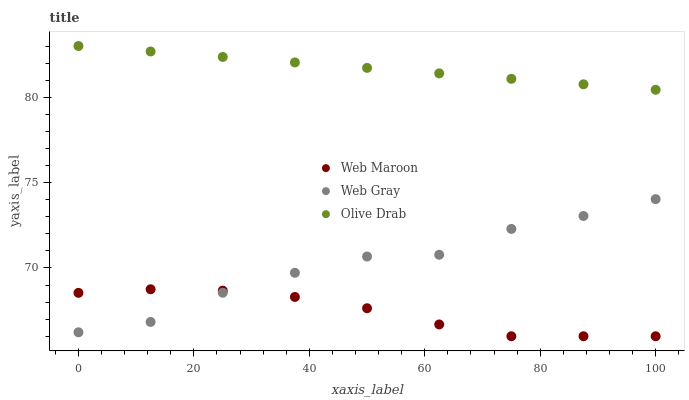Does Web Maroon have the minimum area under the curve?
Answer yes or no. Yes. Does Olive Drab have the maximum area under the curve?
Answer yes or no. Yes. Does Olive Drab have the minimum area under the curve?
Answer yes or no. No. Does Web Maroon have the maximum area under the curve?
Answer yes or no. No. Is Olive Drab the smoothest?
Answer yes or no. Yes. Is Web Gray the roughest?
Answer yes or no. Yes. Is Web Maroon the smoothest?
Answer yes or no. No. Is Web Maroon the roughest?
Answer yes or no. No. Does Web Maroon have the lowest value?
Answer yes or no. Yes. Does Olive Drab have the lowest value?
Answer yes or no. No. Does Olive Drab have the highest value?
Answer yes or no. Yes. Does Web Maroon have the highest value?
Answer yes or no. No. Is Web Maroon less than Olive Drab?
Answer yes or no. Yes. Is Olive Drab greater than Web Gray?
Answer yes or no. Yes. Does Web Gray intersect Web Maroon?
Answer yes or no. Yes. Is Web Gray less than Web Maroon?
Answer yes or no. No. Is Web Gray greater than Web Maroon?
Answer yes or no. No. Does Web Maroon intersect Olive Drab?
Answer yes or no. No. 